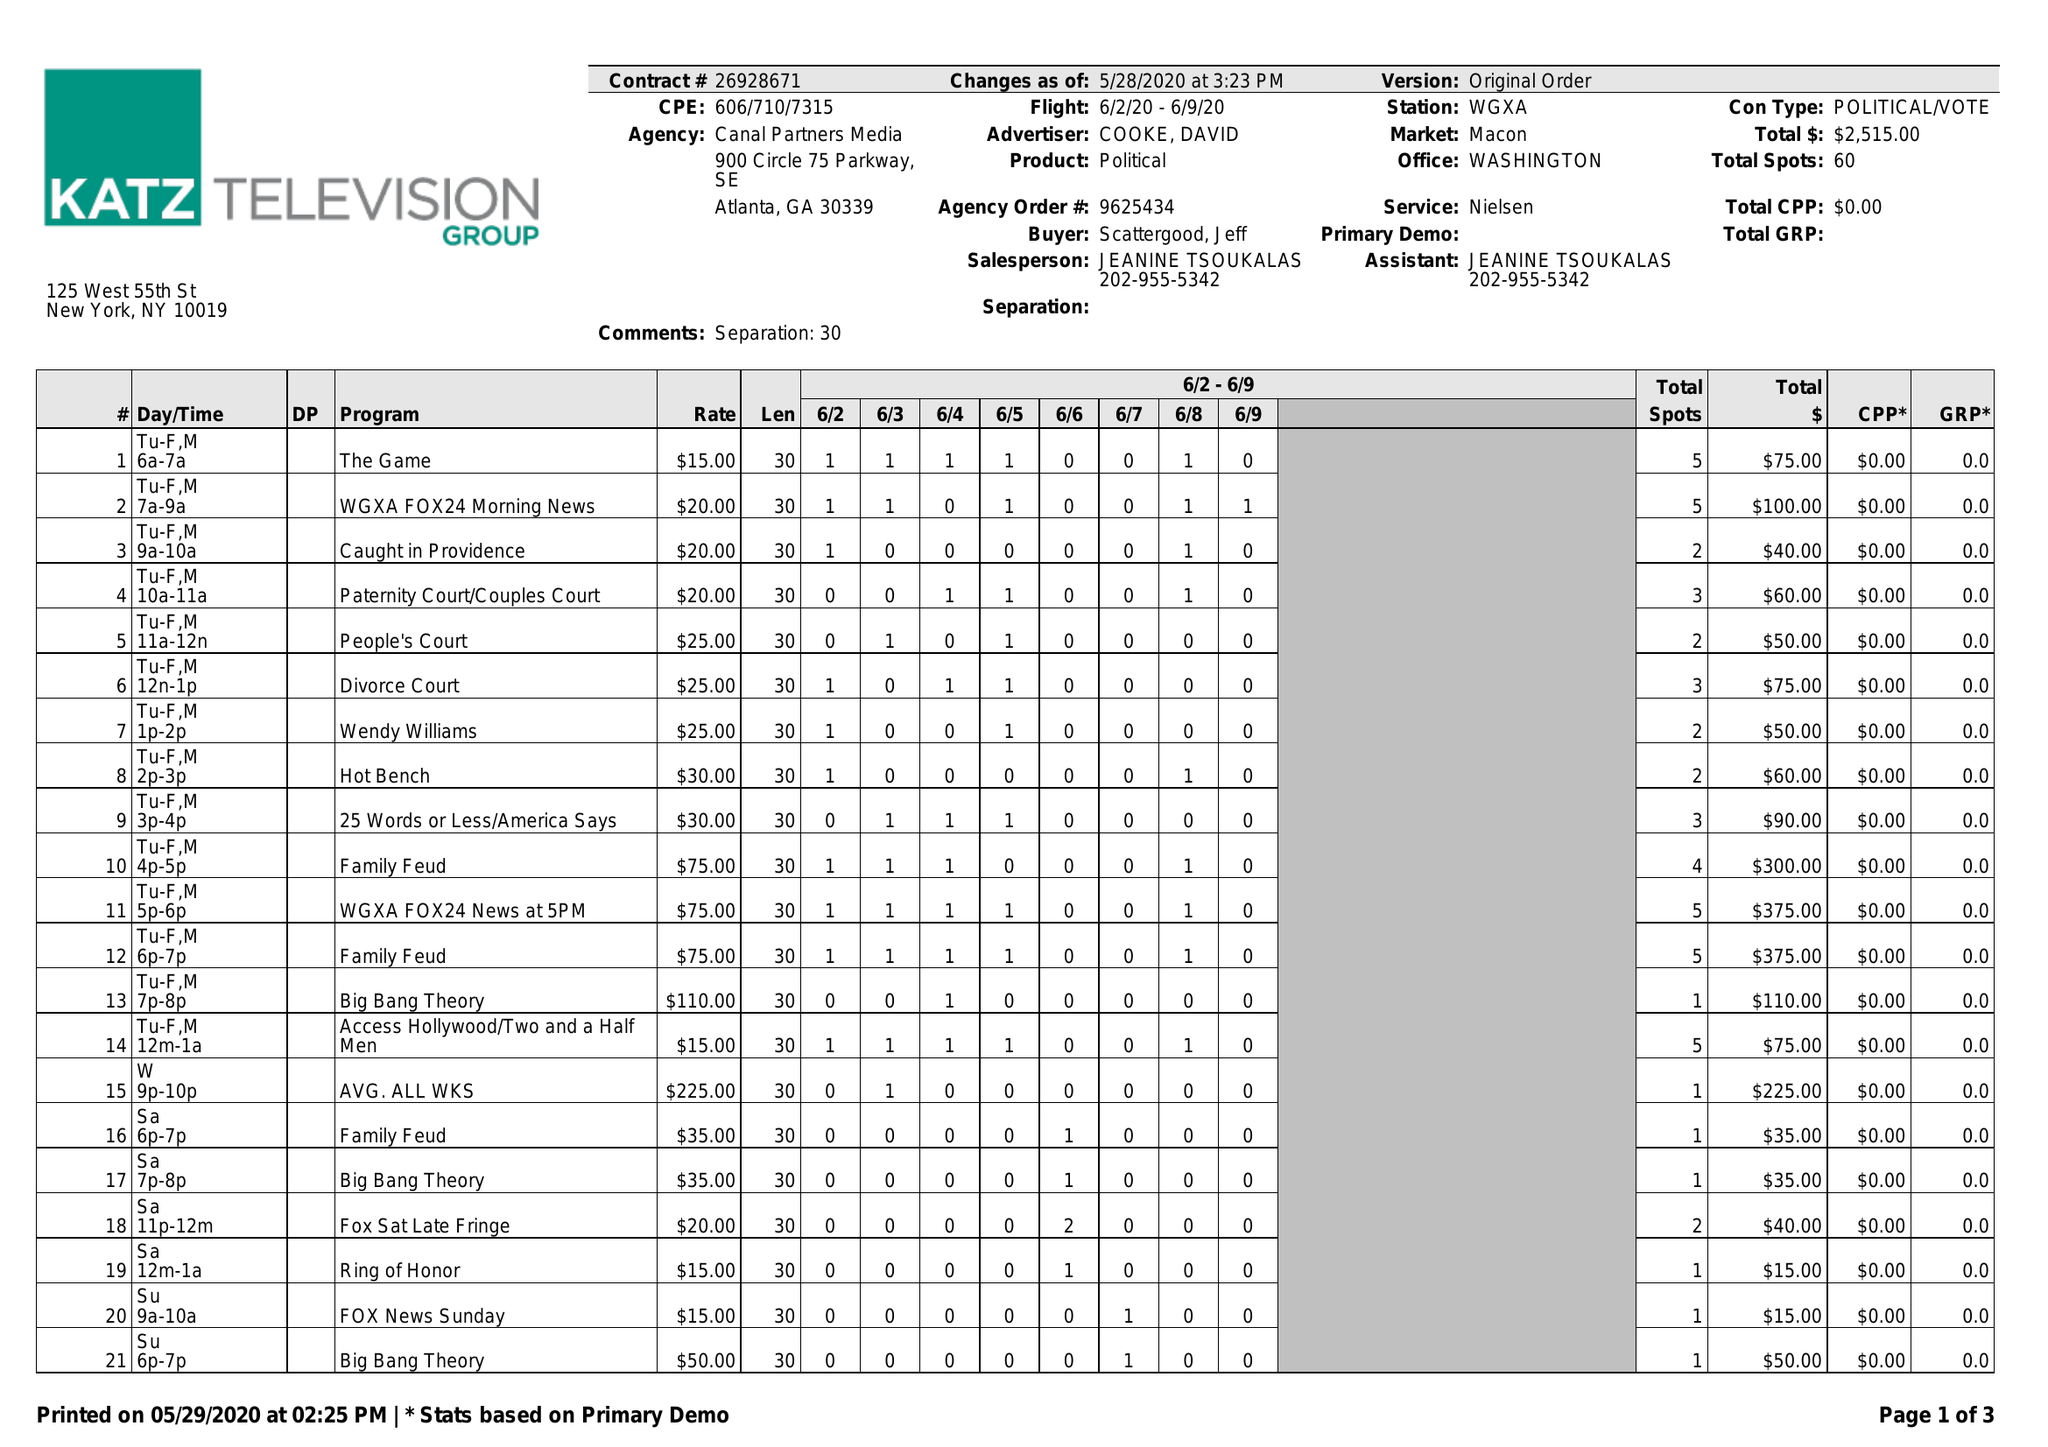What is the value for the gross_amount?
Answer the question using a single word or phrase. 2515.00 